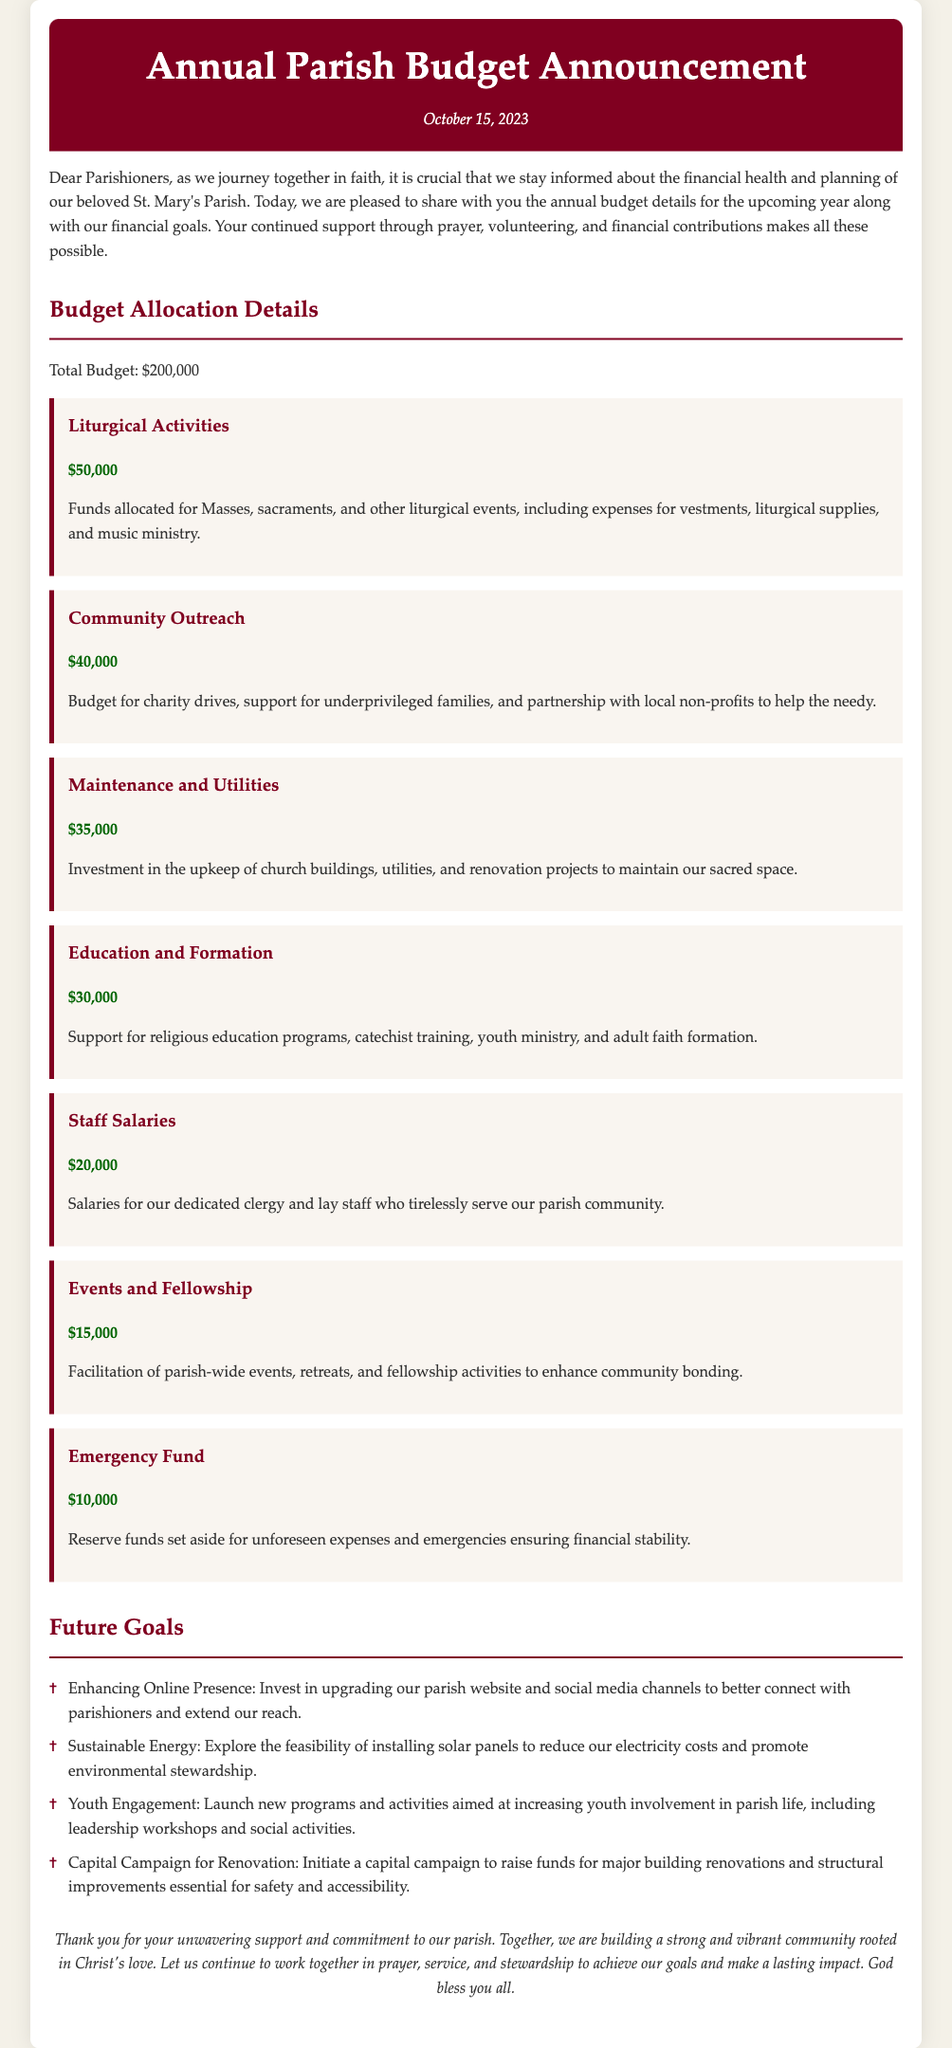What is the total budget? The total budget is explicitly stated in the document as $200,000.
Answer: $200,000 How much is allocated for Community Outreach? The allocation for Community Outreach is specified in the budget section as $40,000.
Answer: $40,000 What is one of the future goals mentioned? The future goals section lists multiple items, one of which is "Enhancing Online Presence."
Answer: Enhancing Online Presence How much is dedicated to Staff Salaries? The budget details indicate that Staff Salaries are allocated $20,000.
Answer: $20,000 On what date was the announcement made? The date of the announcement is provided in the header as October 15, 2023.
Answer: October 15, 2023 What is the allocated amount for Liturgical Activities? The document states that Liturgical Activities are allocated $50,000.
Answer: $50,000 How much is set aside for the Emergency Fund? The Emergency Fund allocation is listed in the budget as $10,000.
Answer: $10,000 What is the budget for Education and Formation? The budget for Education and Formation is indicated as $30,000 in the document.
Answer: $30,000 What is the purpose of the funds for Maintenance and Utilities? The document specifies that Maintenance and Utilities funds are for the upkeep of church buildings, utilities, and renovation projects.
Answer: Upkeep of church buildings 